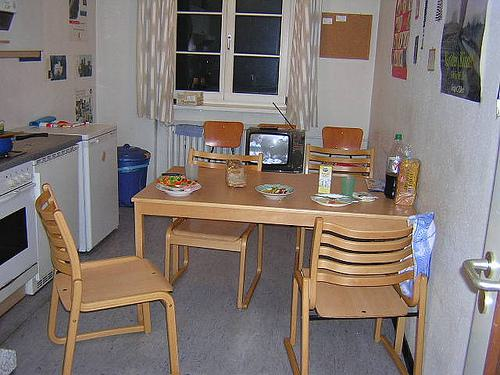Is there any sign of technology in the room? Yes, there's a small television on the table, which is a piece of technology that serves as entertainment in the room. Is the TV modern or outdated? The TV appears to be an older CRT model, indicating that it's somewhat outdated compared to the flat-screen displays commonly used today. 